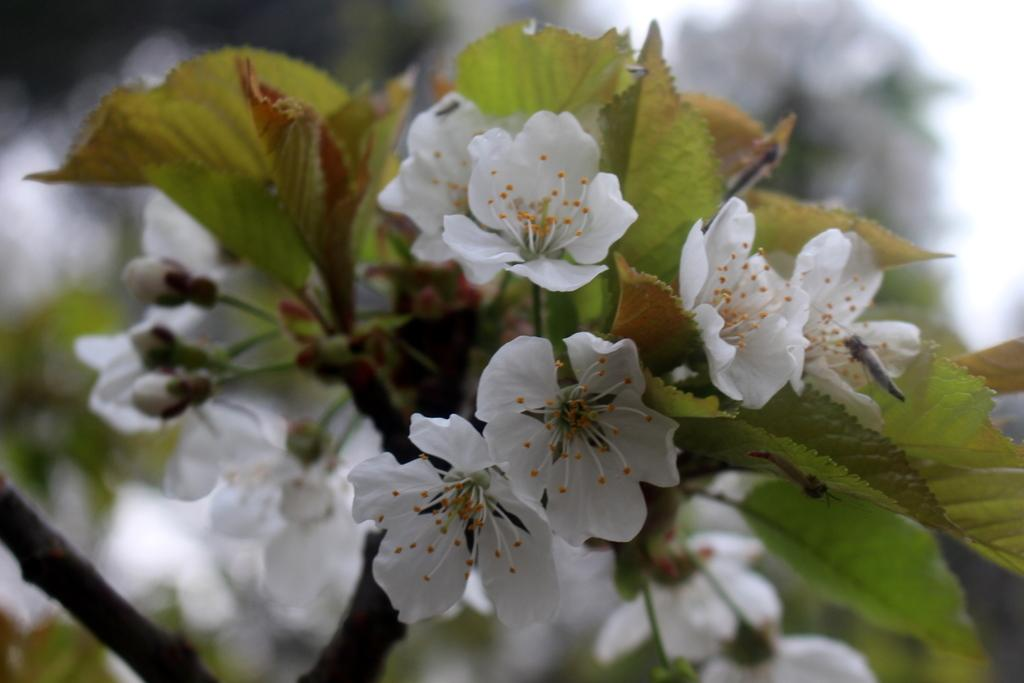What color are the flowers in the image? The flowers in the image are white. What color are the leaves in the image? The leaves in the image are green. Can you describe the overall clarity of the image? The image is slightly blurry. How does the thrill of the wing affect the loss in the image? There is no mention of a wing, thrill, or loss in the image, so this question cannot be answered. 